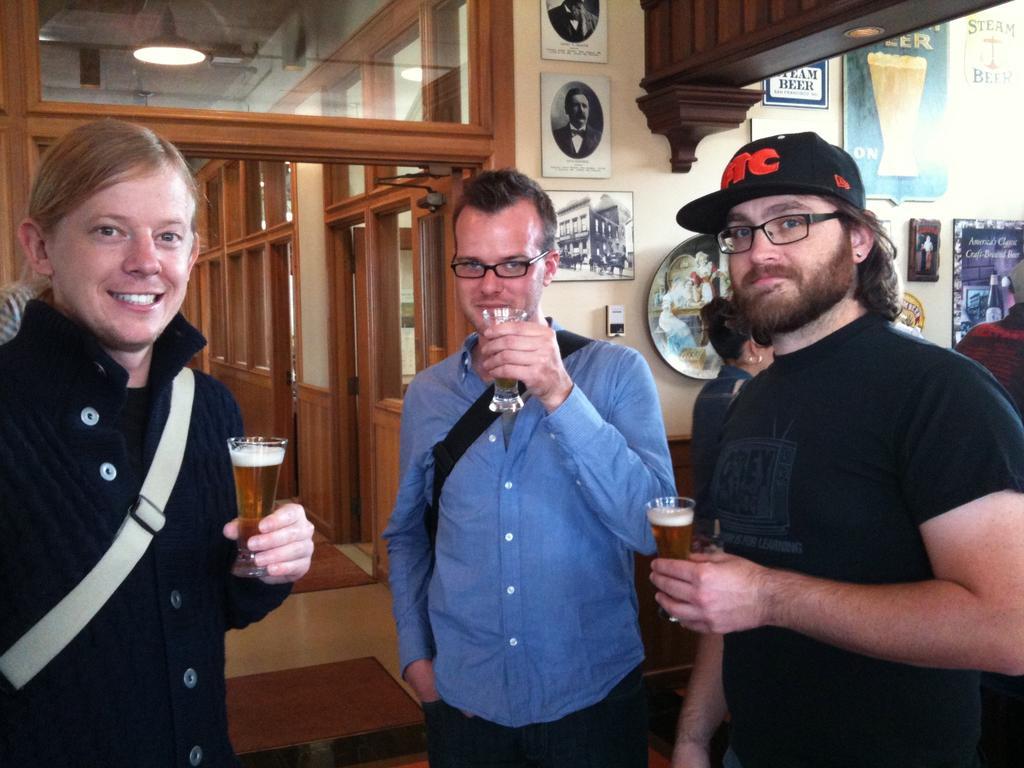Can you describe this image briefly? These 3 persons are standing and holding a glasses. On wall there are different type of pictures and posters. This man wore black t-shirt and spectacles. 